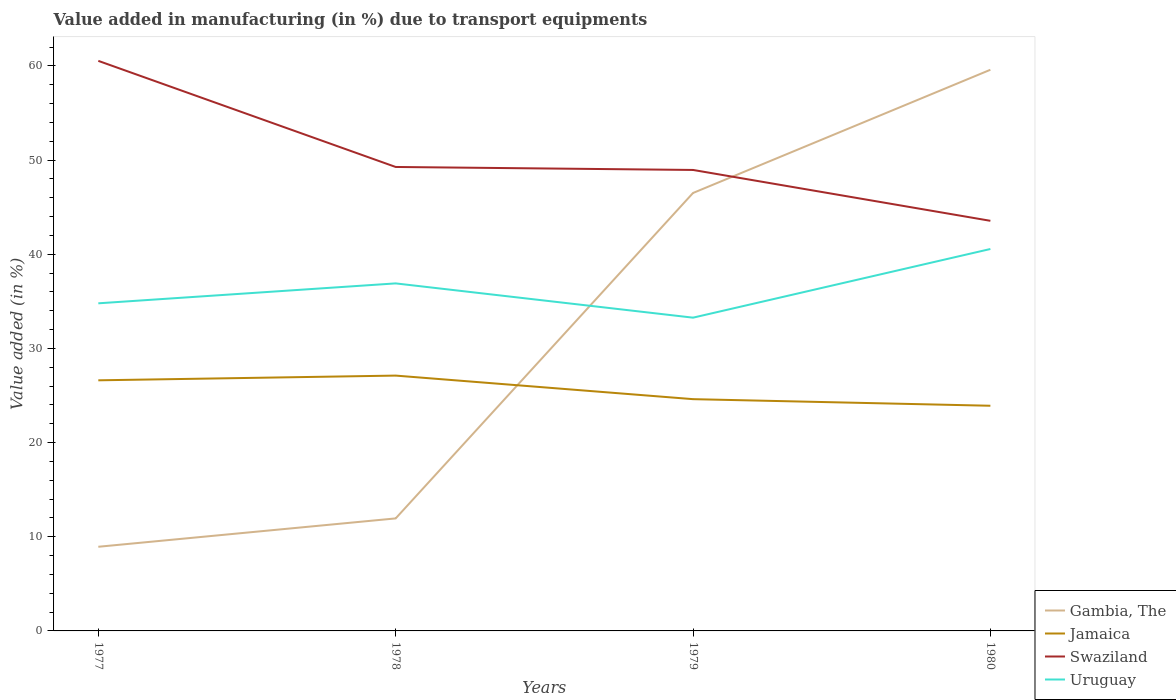Across all years, what is the maximum percentage of value added in manufacturing due to transport equipments in Jamaica?
Your response must be concise. 23.91. What is the total percentage of value added in manufacturing due to transport equipments in Swaziland in the graph?
Your answer should be very brief. 5.72. What is the difference between the highest and the second highest percentage of value added in manufacturing due to transport equipments in Jamaica?
Ensure brevity in your answer.  3.2. What is the difference between the highest and the lowest percentage of value added in manufacturing due to transport equipments in Gambia, The?
Make the answer very short. 2. How many lines are there?
Your response must be concise. 4. How many years are there in the graph?
Ensure brevity in your answer.  4. What is the difference between two consecutive major ticks on the Y-axis?
Ensure brevity in your answer.  10. Does the graph contain grids?
Your answer should be very brief. No. Where does the legend appear in the graph?
Your response must be concise. Bottom right. How many legend labels are there?
Offer a terse response. 4. How are the legend labels stacked?
Make the answer very short. Vertical. What is the title of the graph?
Offer a terse response. Value added in manufacturing (in %) due to transport equipments. Does "Middle East & North Africa (all income levels)" appear as one of the legend labels in the graph?
Make the answer very short. No. What is the label or title of the Y-axis?
Give a very brief answer. Value added (in %). What is the Value added (in %) in Gambia, The in 1977?
Give a very brief answer. 8.94. What is the Value added (in %) of Jamaica in 1977?
Give a very brief answer. 26.61. What is the Value added (in %) of Swaziland in 1977?
Your answer should be compact. 60.54. What is the Value added (in %) of Uruguay in 1977?
Ensure brevity in your answer.  34.79. What is the Value added (in %) of Gambia, The in 1978?
Your answer should be very brief. 11.95. What is the Value added (in %) of Jamaica in 1978?
Your answer should be compact. 27.11. What is the Value added (in %) of Swaziland in 1978?
Offer a very short reply. 49.27. What is the Value added (in %) of Uruguay in 1978?
Give a very brief answer. 36.91. What is the Value added (in %) in Gambia, The in 1979?
Your answer should be compact. 46.51. What is the Value added (in %) of Jamaica in 1979?
Offer a terse response. 24.61. What is the Value added (in %) of Swaziland in 1979?
Provide a succinct answer. 48.95. What is the Value added (in %) in Uruguay in 1979?
Give a very brief answer. 33.27. What is the Value added (in %) of Gambia, The in 1980?
Your answer should be compact. 59.59. What is the Value added (in %) in Jamaica in 1980?
Provide a succinct answer. 23.91. What is the Value added (in %) of Swaziland in 1980?
Your answer should be compact. 43.55. What is the Value added (in %) of Uruguay in 1980?
Keep it short and to the point. 40.56. Across all years, what is the maximum Value added (in %) in Gambia, The?
Your answer should be compact. 59.59. Across all years, what is the maximum Value added (in %) of Jamaica?
Your answer should be very brief. 27.11. Across all years, what is the maximum Value added (in %) of Swaziland?
Ensure brevity in your answer.  60.54. Across all years, what is the maximum Value added (in %) in Uruguay?
Your response must be concise. 40.56. Across all years, what is the minimum Value added (in %) of Gambia, The?
Offer a very short reply. 8.94. Across all years, what is the minimum Value added (in %) of Jamaica?
Provide a succinct answer. 23.91. Across all years, what is the minimum Value added (in %) of Swaziland?
Offer a very short reply. 43.55. Across all years, what is the minimum Value added (in %) in Uruguay?
Ensure brevity in your answer.  33.27. What is the total Value added (in %) of Gambia, The in the graph?
Your response must be concise. 126.98. What is the total Value added (in %) in Jamaica in the graph?
Offer a very short reply. 102.25. What is the total Value added (in %) of Swaziland in the graph?
Give a very brief answer. 202.31. What is the total Value added (in %) in Uruguay in the graph?
Offer a terse response. 145.52. What is the difference between the Value added (in %) in Gambia, The in 1977 and that in 1978?
Offer a very short reply. -3.01. What is the difference between the Value added (in %) in Jamaica in 1977 and that in 1978?
Offer a very short reply. -0.5. What is the difference between the Value added (in %) in Swaziland in 1977 and that in 1978?
Your response must be concise. 11.27. What is the difference between the Value added (in %) of Uruguay in 1977 and that in 1978?
Your answer should be compact. -2.12. What is the difference between the Value added (in %) in Gambia, The in 1977 and that in 1979?
Offer a terse response. -37.57. What is the difference between the Value added (in %) in Jamaica in 1977 and that in 1979?
Keep it short and to the point. 2. What is the difference between the Value added (in %) of Swaziland in 1977 and that in 1979?
Your answer should be compact. 11.58. What is the difference between the Value added (in %) in Uruguay in 1977 and that in 1979?
Give a very brief answer. 1.52. What is the difference between the Value added (in %) in Gambia, The in 1977 and that in 1980?
Give a very brief answer. -50.65. What is the difference between the Value added (in %) in Jamaica in 1977 and that in 1980?
Make the answer very short. 2.7. What is the difference between the Value added (in %) of Swaziland in 1977 and that in 1980?
Provide a succinct answer. 16.98. What is the difference between the Value added (in %) in Uruguay in 1977 and that in 1980?
Provide a short and direct response. -5.77. What is the difference between the Value added (in %) of Gambia, The in 1978 and that in 1979?
Provide a succinct answer. -34.56. What is the difference between the Value added (in %) in Jamaica in 1978 and that in 1979?
Offer a very short reply. 2.5. What is the difference between the Value added (in %) of Swaziland in 1978 and that in 1979?
Provide a short and direct response. 0.32. What is the difference between the Value added (in %) of Uruguay in 1978 and that in 1979?
Offer a terse response. 3.64. What is the difference between the Value added (in %) in Gambia, The in 1978 and that in 1980?
Your response must be concise. -47.64. What is the difference between the Value added (in %) of Jamaica in 1978 and that in 1980?
Your response must be concise. 3.2. What is the difference between the Value added (in %) of Swaziland in 1978 and that in 1980?
Your response must be concise. 5.72. What is the difference between the Value added (in %) in Uruguay in 1978 and that in 1980?
Provide a short and direct response. -3.65. What is the difference between the Value added (in %) in Gambia, The in 1979 and that in 1980?
Keep it short and to the point. -13.09. What is the difference between the Value added (in %) in Jamaica in 1979 and that in 1980?
Offer a very short reply. 0.7. What is the difference between the Value added (in %) of Swaziland in 1979 and that in 1980?
Keep it short and to the point. 5.4. What is the difference between the Value added (in %) in Uruguay in 1979 and that in 1980?
Make the answer very short. -7.29. What is the difference between the Value added (in %) of Gambia, The in 1977 and the Value added (in %) of Jamaica in 1978?
Your answer should be very brief. -18.18. What is the difference between the Value added (in %) of Gambia, The in 1977 and the Value added (in %) of Swaziland in 1978?
Make the answer very short. -40.33. What is the difference between the Value added (in %) in Gambia, The in 1977 and the Value added (in %) in Uruguay in 1978?
Ensure brevity in your answer.  -27.97. What is the difference between the Value added (in %) of Jamaica in 1977 and the Value added (in %) of Swaziland in 1978?
Your answer should be very brief. -22.66. What is the difference between the Value added (in %) of Jamaica in 1977 and the Value added (in %) of Uruguay in 1978?
Ensure brevity in your answer.  -10.29. What is the difference between the Value added (in %) in Swaziland in 1977 and the Value added (in %) in Uruguay in 1978?
Provide a succinct answer. 23.63. What is the difference between the Value added (in %) in Gambia, The in 1977 and the Value added (in %) in Jamaica in 1979?
Ensure brevity in your answer.  -15.68. What is the difference between the Value added (in %) in Gambia, The in 1977 and the Value added (in %) in Swaziland in 1979?
Offer a terse response. -40.02. What is the difference between the Value added (in %) of Gambia, The in 1977 and the Value added (in %) of Uruguay in 1979?
Your response must be concise. -24.33. What is the difference between the Value added (in %) in Jamaica in 1977 and the Value added (in %) in Swaziland in 1979?
Offer a terse response. -22.34. What is the difference between the Value added (in %) in Jamaica in 1977 and the Value added (in %) in Uruguay in 1979?
Your answer should be very brief. -6.65. What is the difference between the Value added (in %) in Swaziland in 1977 and the Value added (in %) in Uruguay in 1979?
Keep it short and to the point. 27.27. What is the difference between the Value added (in %) of Gambia, The in 1977 and the Value added (in %) of Jamaica in 1980?
Your response must be concise. -14.97. What is the difference between the Value added (in %) in Gambia, The in 1977 and the Value added (in %) in Swaziland in 1980?
Ensure brevity in your answer.  -34.61. What is the difference between the Value added (in %) in Gambia, The in 1977 and the Value added (in %) in Uruguay in 1980?
Your response must be concise. -31.62. What is the difference between the Value added (in %) of Jamaica in 1977 and the Value added (in %) of Swaziland in 1980?
Your answer should be very brief. -16.94. What is the difference between the Value added (in %) of Jamaica in 1977 and the Value added (in %) of Uruguay in 1980?
Ensure brevity in your answer.  -13.95. What is the difference between the Value added (in %) in Swaziland in 1977 and the Value added (in %) in Uruguay in 1980?
Give a very brief answer. 19.98. What is the difference between the Value added (in %) of Gambia, The in 1978 and the Value added (in %) of Jamaica in 1979?
Keep it short and to the point. -12.66. What is the difference between the Value added (in %) in Gambia, The in 1978 and the Value added (in %) in Swaziland in 1979?
Make the answer very short. -37. What is the difference between the Value added (in %) of Gambia, The in 1978 and the Value added (in %) of Uruguay in 1979?
Ensure brevity in your answer.  -21.32. What is the difference between the Value added (in %) in Jamaica in 1978 and the Value added (in %) in Swaziland in 1979?
Offer a very short reply. -21.84. What is the difference between the Value added (in %) of Jamaica in 1978 and the Value added (in %) of Uruguay in 1979?
Keep it short and to the point. -6.15. What is the difference between the Value added (in %) in Swaziland in 1978 and the Value added (in %) in Uruguay in 1979?
Provide a succinct answer. 16. What is the difference between the Value added (in %) of Gambia, The in 1978 and the Value added (in %) of Jamaica in 1980?
Your answer should be very brief. -11.96. What is the difference between the Value added (in %) of Gambia, The in 1978 and the Value added (in %) of Swaziland in 1980?
Offer a very short reply. -31.6. What is the difference between the Value added (in %) of Gambia, The in 1978 and the Value added (in %) of Uruguay in 1980?
Provide a short and direct response. -28.61. What is the difference between the Value added (in %) of Jamaica in 1978 and the Value added (in %) of Swaziland in 1980?
Keep it short and to the point. -16.44. What is the difference between the Value added (in %) of Jamaica in 1978 and the Value added (in %) of Uruguay in 1980?
Your answer should be very brief. -13.44. What is the difference between the Value added (in %) in Swaziland in 1978 and the Value added (in %) in Uruguay in 1980?
Your answer should be very brief. 8.71. What is the difference between the Value added (in %) of Gambia, The in 1979 and the Value added (in %) of Jamaica in 1980?
Ensure brevity in your answer.  22.59. What is the difference between the Value added (in %) of Gambia, The in 1979 and the Value added (in %) of Swaziland in 1980?
Provide a succinct answer. 2.95. What is the difference between the Value added (in %) in Gambia, The in 1979 and the Value added (in %) in Uruguay in 1980?
Provide a succinct answer. 5.95. What is the difference between the Value added (in %) in Jamaica in 1979 and the Value added (in %) in Swaziland in 1980?
Provide a succinct answer. -18.94. What is the difference between the Value added (in %) in Jamaica in 1979 and the Value added (in %) in Uruguay in 1980?
Your answer should be very brief. -15.95. What is the difference between the Value added (in %) of Swaziland in 1979 and the Value added (in %) of Uruguay in 1980?
Your answer should be very brief. 8.39. What is the average Value added (in %) in Gambia, The per year?
Ensure brevity in your answer.  31.75. What is the average Value added (in %) in Jamaica per year?
Your answer should be very brief. 25.56. What is the average Value added (in %) of Swaziland per year?
Provide a succinct answer. 50.58. What is the average Value added (in %) in Uruguay per year?
Give a very brief answer. 36.38. In the year 1977, what is the difference between the Value added (in %) of Gambia, The and Value added (in %) of Jamaica?
Provide a short and direct response. -17.68. In the year 1977, what is the difference between the Value added (in %) in Gambia, The and Value added (in %) in Swaziland?
Make the answer very short. -51.6. In the year 1977, what is the difference between the Value added (in %) in Gambia, The and Value added (in %) in Uruguay?
Ensure brevity in your answer.  -25.85. In the year 1977, what is the difference between the Value added (in %) in Jamaica and Value added (in %) in Swaziland?
Make the answer very short. -33.92. In the year 1977, what is the difference between the Value added (in %) in Jamaica and Value added (in %) in Uruguay?
Provide a short and direct response. -8.18. In the year 1977, what is the difference between the Value added (in %) in Swaziland and Value added (in %) in Uruguay?
Provide a short and direct response. 25.75. In the year 1978, what is the difference between the Value added (in %) in Gambia, The and Value added (in %) in Jamaica?
Keep it short and to the point. -15.17. In the year 1978, what is the difference between the Value added (in %) of Gambia, The and Value added (in %) of Swaziland?
Offer a very short reply. -37.32. In the year 1978, what is the difference between the Value added (in %) in Gambia, The and Value added (in %) in Uruguay?
Your answer should be compact. -24.96. In the year 1978, what is the difference between the Value added (in %) in Jamaica and Value added (in %) in Swaziland?
Keep it short and to the point. -22.15. In the year 1978, what is the difference between the Value added (in %) in Jamaica and Value added (in %) in Uruguay?
Offer a terse response. -9.79. In the year 1978, what is the difference between the Value added (in %) in Swaziland and Value added (in %) in Uruguay?
Your response must be concise. 12.36. In the year 1979, what is the difference between the Value added (in %) of Gambia, The and Value added (in %) of Jamaica?
Provide a short and direct response. 21.89. In the year 1979, what is the difference between the Value added (in %) of Gambia, The and Value added (in %) of Swaziland?
Provide a succinct answer. -2.45. In the year 1979, what is the difference between the Value added (in %) in Gambia, The and Value added (in %) in Uruguay?
Provide a succinct answer. 13.24. In the year 1979, what is the difference between the Value added (in %) in Jamaica and Value added (in %) in Swaziland?
Offer a terse response. -24.34. In the year 1979, what is the difference between the Value added (in %) in Jamaica and Value added (in %) in Uruguay?
Give a very brief answer. -8.65. In the year 1979, what is the difference between the Value added (in %) in Swaziland and Value added (in %) in Uruguay?
Your answer should be very brief. 15.69. In the year 1980, what is the difference between the Value added (in %) of Gambia, The and Value added (in %) of Jamaica?
Provide a succinct answer. 35.68. In the year 1980, what is the difference between the Value added (in %) in Gambia, The and Value added (in %) in Swaziland?
Ensure brevity in your answer.  16.04. In the year 1980, what is the difference between the Value added (in %) in Gambia, The and Value added (in %) in Uruguay?
Provide a succinct answer. 19.03. In the year 1980, what is the difference between the Value added (in %) in Jamaica and Value added (in %) in Swaziland?
Offer a very short reply. -19.64. In the year 1980, what is the difference between the Value added (in %) of Jamaica and Value added (in %) of Uruguay?
Ensure brevity in your answer.  -16.65. In the year 1980, what is the difference between the Value added (in %) of Swaziland and Value added (in %) of Uruguay?
Provide a short and direct response. 2.99. What is the ratio of the Value added (in %) of Gambia, The in 1977 to that in 1978?
Offer a very short reply. 0.75. What is the ratio of the Value added (in %) of Jamaica in 1977 to that in 1978?
Keep it short and to the point. 0.98. What is the ratio of the Value added (in %) in Swaziland in 1977 to that in 1978?
Your answer should be very brief. 1.23. What is the ratio of the Value added (in %) in Uruguay in 1977 to that in 1978?
Provide a short and direct response. 0.94. What is the ratio of the Value added (in %) of Gambia, The in 1977 to that in 1979?
Your response must be concise. 0.19. What is the ratio of the Value added (in %) of Jamaica in 1977 to that in 1979?
Your answer should be compact. 1.08. What is the ratio of the Value added (in %) of Swaziland in 1977 to that in 1979?
Your answer should be compact. 1.24. What is the ratio of the Value added (in %) in Uruguay in 1977 to that in 1979?
Keep it short and to the point. 1.05. What is the ratio of the Value added (in %) of Jamaica in 1977 to that in 1980?
Your answer should be very brief. 1.11. What is the ratio of the Value added (in %) in Swaziland in 1977 to that in 1980?
Ensure brevity in your answer.  1.39. What is the ratio of the Value added (in %) in Uruguay in 1977 to that in 1980?
Your answer should be very brief. 0.86. What is the ratio of the Value added (in %) in Gambia, The in 1978 to that in 1979?
Offer a terse response. 0.26. What is the ratio of the Value added (in %) of Jamaica in 1978 to that in 1979?
Keep it short and to the point. 1.1. What is the ratio of the Value added (in %) of Uruguay in 1978 to that in 1979?
Provide a succinct answer. 1.11. What is the ratio of the Value added (in %) in Gambia, The in 1978 to that in 1980?
Offer a terse response. 0.2. What is the ratio of the Value added (in %) of Jamaica in 1978 to that in 1980?
Ensure brevity in your answer.  1.13. What is the ratio of the Value added (in %) of Swaziland in 1978 to that in 1980?
Make the answer very short. 1.13. What is the ratio of the Value added (in %) of Uruguay in 1978 to that in 1980?
Provide a succinct answer. 0.91. What is the ratio of the Value added (in %) of Gambia, The in 1979 to that in 1980?
Your response must be concise. 0.78. What is the ratio of the Value added (in %) in Jamaica in 1979 to that in 1980?
Your answer should be compact. 1.03. What is the ratio of the Value added (in %) in Swaziland in 1979 to that in 1980?
Give a very brief answer. 1.12. What is the ratio of the Value added (in %) of Uruguay in 1979 to that in 1980?
Your answer should be very brief. 0.82. What is the difference between the highest and the second highest Value added (in %) of Gambia, The?
Make the answer very short. 13.09. What is the difference between the highest and the second highest Value added (in %) of Jamaica?
Give a very brief answer. 0.5. What is the difference between the highest and the second highest Value added (in %) in Swaziland?
Ensure brevity in your answer.  11.27. What is the difference between the highest and the second highest Value added (in %) of Uruguay?
Your answer should be compact. 3.65. What is the difference between the highest and the lowest Value added (in %) in Gambia, The?
Give a very brief answer. 50.65. What is the difference between the highest and the lowest Value added (in %) in Jamaica?
Your answer should be compact. 3.2. What is the difference between the highest and the lowest Value added (in %) in Swaziland?
Your answer should be very brief. 16.98. What is the difference between the highest and the lowest Value added (in %) in Uruguay?
Offer a terse response. 7.29. 